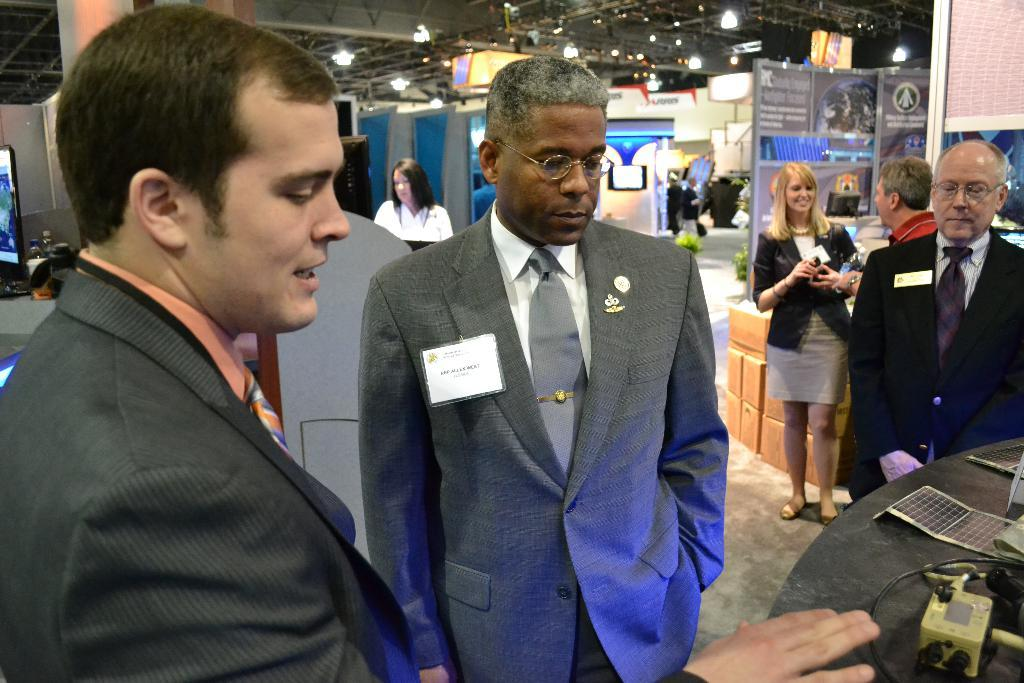Who or what can be seen in the image? There are people in the image. What is visible in the background of the image? There are stalls in the background of the image. What is located at the top of the image? There is a ceiling with lights visible at the top of the image. What type of worm can be seen crawling on the people in the image? There are no worms present in the image; it features people and stalls in the background. 